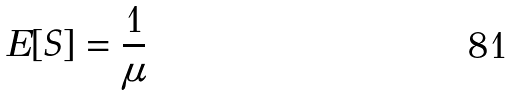Convert formula to latex. <formula><loc_0><loc_0><loc_500><loc_500>E [ S ] = \frac { 1 } { \mu }</formula> 